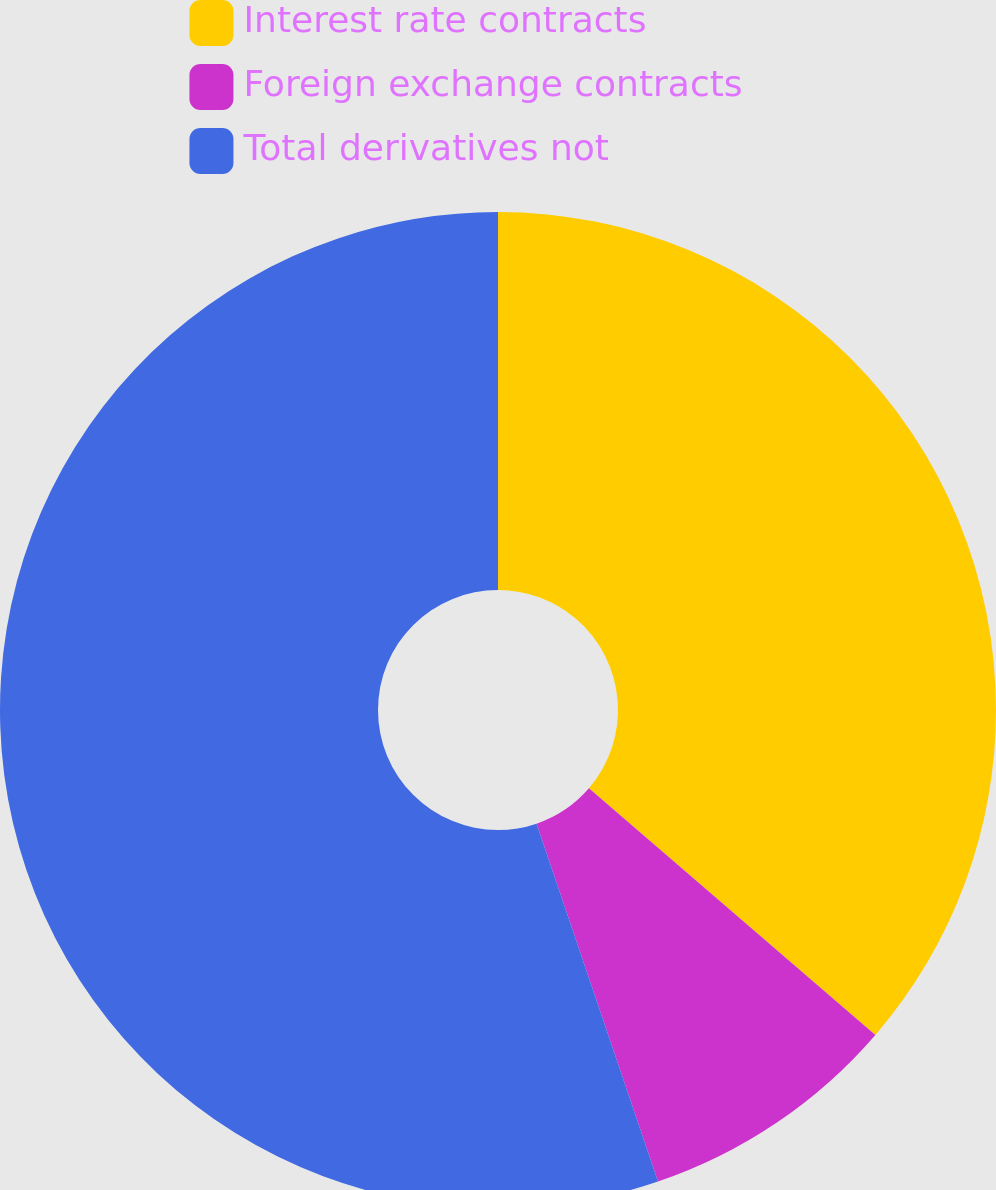Convert chart to OTSL. <chart><loc_0><loc_0><loc_500><loc_500><pie_chart><fcel>Interest rate contracts<fcel>Foreign exchange contracts<fcel>Total derivatives not<nl><fcel>36.31%<fcel>8.48%<fcel>55.2%<nl></chart> 